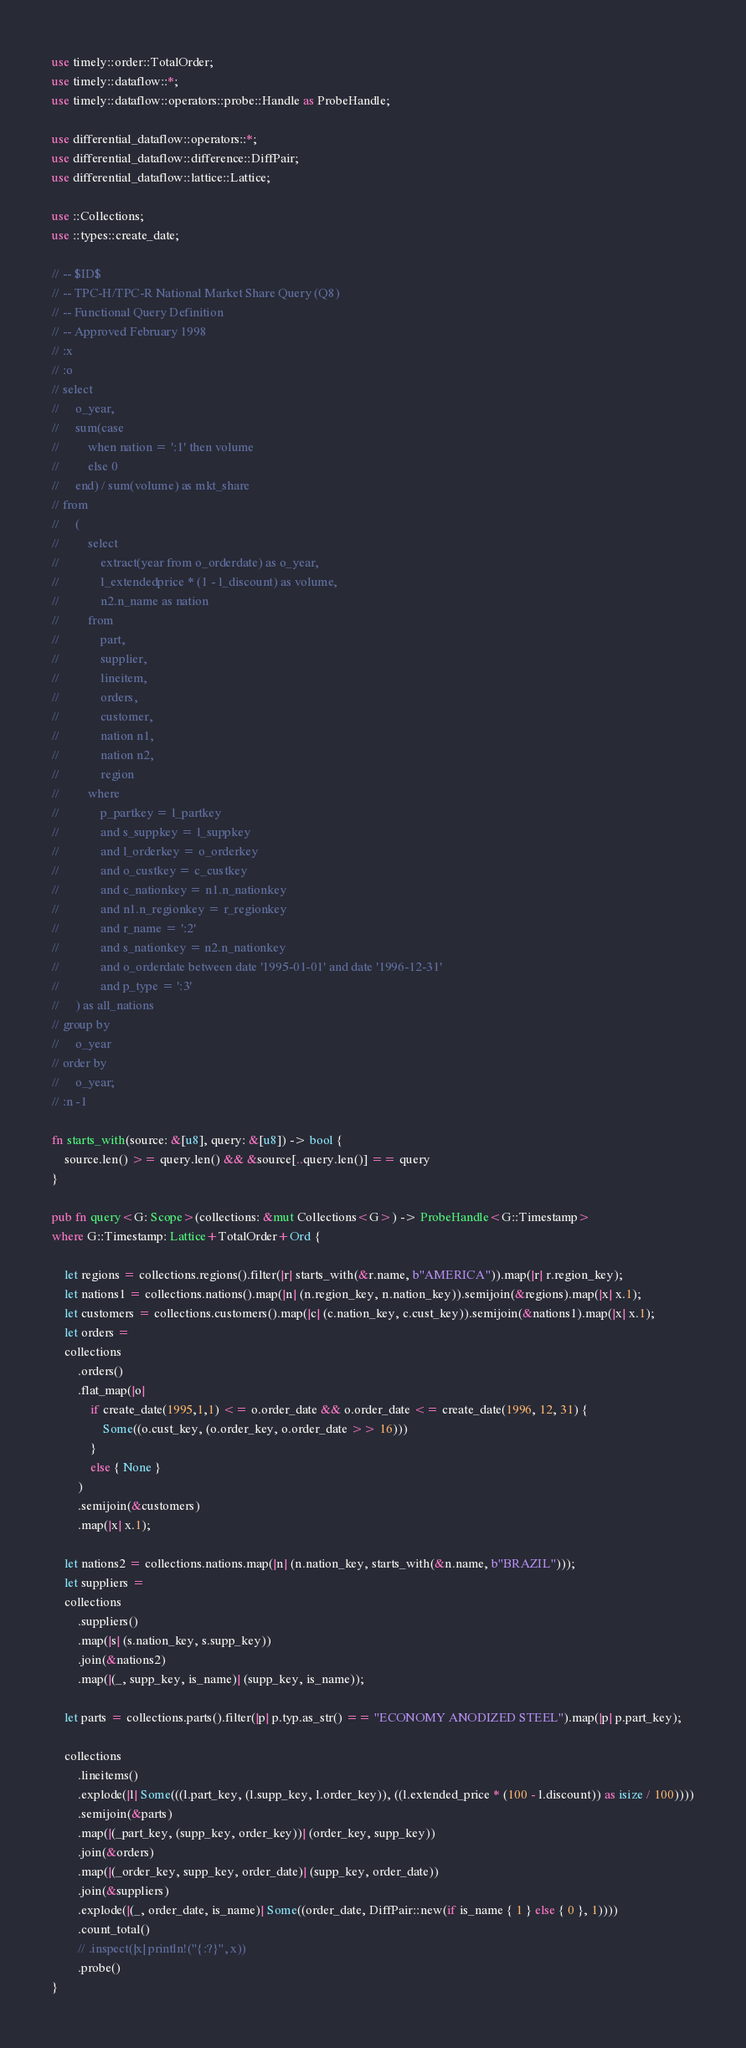Convert code to text. <code><loc_0><loc_0><loc_500><loc_500><_Rust_>use timely::order::TotalOrder;
use timely::dataflow::*;
use timely::dataflow::operators::probe::Handle as ProbeHandle;

use differential_dataflow::operators::*;
use differential_dataflow::difference::DiffPair;
use differential_dataflow::lattice::Lattice;

use ::Collections;
use ::types::create_date;

// -- $ID$
// -- TPC-H/TPC-R National Market Share Query (Q8)
// -- Functional Query Definition
// -- Approved February 1998
// :x
// :o
// select
//     o_year,
//     sum(case
//         when nation = ':1' then volume
//         else 0
//     end) / sum(volume) as mkt_share
// from
//     (
//         select
//             extract(year from o_orderdate) as o_year,
//             l_extendedprice * (1 - l_discount) as volume,
//             n2.n_name as nation
//         from
//             part,
//             supplier,
//             lineitem,
//             orders,
//             customer,
//             nation n1,
//             nation n2,
//             region
//         where
//             p_partkey = l_partkey
//             and s_suppkey = l_suppkey
//             and l_orderkey = o_orderkey
//             and o_custkey = c_custkey
//             and c_nationkey = n1.n_nationkey
//             and n1.n_regionkey = r_regionkey
//             and r_name = ':2'
//             and s_nationkey = n2.n_nationkey
//             and o_orderdate between date '1995-01-01' and date '1996-12-31'
//             and p_type = ':3'
//     ) as all_nations
// group by
//     o_year
// order by
//     o_year;
// :n -1

fn starts_with(source: &[u8], query: &[u8]) -> bool {
    source.len() >= query.len() && &source[..query.len()] == query
}

pub fn query<G: Scope>(collections: &mut Collections<G>) -> ProbeHandle<G::Timestamp> 
where G::Timestamp: Lattice+TotalOrder+Ord {

    let regions = collections.regions().filter(|r| starts_with(&r.name, b"AMERICA")).map(|r| r.region_key);
    let nations1 = collections.nations().map(|n| (n.region_key, n.nation_key)).semijoin(&regions).map(|x| x.1);
    let customers = collections.customers().map(|c| (c.nation_key, c.cust_key)).semijoin(&nations1).map(|x| x.1);
    let orders = 
    collections
        .orders()
        .flat_map(|o|
            if create_date(1995,1,1) <= o.order_date && o.order_date <= create_date(1996, 12, 31) {
                Some((o.cust_key, (o.order_key, o.order_date >> 16)))
            }
            else { None }
        )
        .semijoin(&customers)
        .map(|x| x.1);

    let nations2 = collections.nations.map(|n| (n.nation_key, starts_with(&n.name, b"BRAZIL")));
    let suppliers = 
    collections
        .suppliers()
        .map(|s| (s.nation_key, s.supp_key))
        .join(&nations2)
        .map(|(_, supp_key, is_name)| (supp_key, is_name));

    let parts = collections.parts().filter(|p| p.typ.as_str() == "ECONOMY ANODIZED STEEL").map(|p| p.part_key);

    collections
        .lineitems()
        .explode(|l| Some(((l.part_key, (l.supp_key, l.order_key)), ((l.extended_price * (100 - l.discount)) as isize / 100))))
        .semijoin(&parts)
        .map(|(_part_key, (supp_key, order_key))| (order_key, supp_key))
        .join(&orders)
        .map(|(_order_key, supp_key, order_date)| (supp_key, order_date))
        .join(&suppliers)
        .explode(|(_, order_date, is_name)| Some((order_date, DiffPair::new(if is_name { 1 } else { 0 }, 1))))
        .count_total()
        // .inspect(|x| println!("{:?}", x))
        .probe()
}</code> 